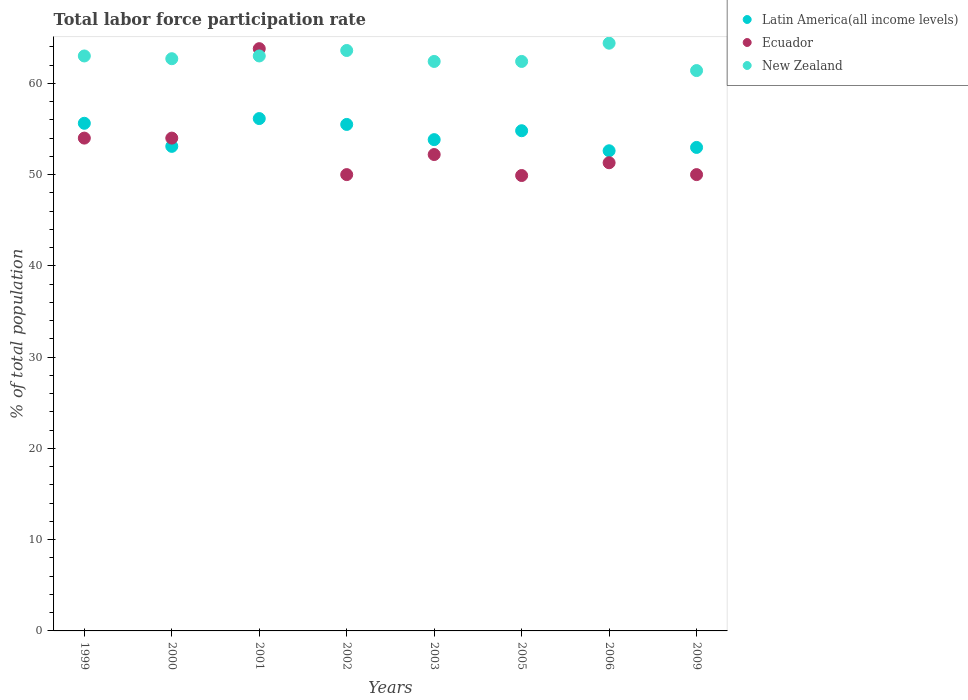What is the total labor force participation rate in Ecuador in 2003?
Provide a succinct answer. 52.2. Across all years, what is the maximum total labor force participation rate in New Zealand?
Your answer should be compact. 64.4. Across all years, what is the minimum total labor force participation rate in New Zealand?
Give a very brief answer. 61.4. In which year was the total labor force participation rate in Latin America(all income levels) maximum?
Your answer should be very brief. 2001. In which year was the total labor force participation rate in New Zealand minimum?
Offer a very short reply. 2009. What is the total total labor force participation rate in Latin America(all income levels) in the graph?
Give a very brief answer. 434.59. What is the difference between the total labor force participation rate in New Zealand in 1999 and that in 2003?
Offer a very short reply. 0.6. What is the difference between the total labor force participation rate in Ecuador in 2003 and the total labor force participation rate in New Zealand in 2000?
Ensure brevity in your answer.  -10.5. What is the average total labor force participation rate in Latin America(all income levels) per year?
Make the answer very short. 54.32. In the year 2005, what is the difference between the total labor force participation rate in Ecuador and total labor force participation rate in New Zealand?
Offer a terse response. -12.5. What is the ratio of the total labor force participation rate in New Zealand in 2002 to that in 2009?
Ensure brevity in your answer.  1.04. Is the total labor force participation rate in Ecuador in 2000 less than that in 2001?
Your answer should be compact. Yes. What is the difference between the highest and the second highest total labor force participation rate in Ecuador?
Give a very brief answer. 9.8. What is the difference between the highest and the lowest total labor force participation rate in Ecuador?
Provide a short and direct response. 13.9. In how many years, is the total labor force participation rate in Latin America(all income levels) greater than the average total labor force participation rate in Latin America(all income levels) taken over all years?
Make the answer very short. 4. Is it the case that in every year, the sum of the total labor force participation rate in New Zealand and total labor force participation rate in Ecuador  is greater than the total labor force participation rate in Latin America(all income levels)?
Offer a very short reply. Yes. Is the total labor force participation rate in Ecuador strictly less than the total labor force participation rate in Latin America(all income levels) over the years?
Provide a short and direct response. No. How many years are there in the graph?
Provide a succinct answer. 8. What is the difference between two consecutive major ticks on the Y-axis?
Give a very brief answer. 10. Does the graph contain any zero values?
Give a very brief answer. No. Where does the legend appear in the graph?
Ensure brevity in your answer.  Top right. How many legend labels are there?
Offer a terse response. 3. How are the legend labels stacked?
Offer a very short reply. Vertical. What is the title of the graph?
Give a very brief answer. Total labor force participation rate. What is the label or title of the Y-axis?
Provide a succinct answer. % of total population. What is the % of total population of Latin America(all income levels) in 1999?
Ensure brevity in your answer.  55.62. What is the % of total population of Latin America(all income levels) in 2000?
Offer a terse response. 53.09. What is the % of total population of Ecuador in 2000?
Make the answer very short. 54. What is the % of total population in New Zealand in 2000?
Provide a succinct answer. 62.7. What is the % of total population in Latin America(all income levels) in 2001?
Offer a terse response. 56.14. What is the % of total population of Ecuador in 2001?
Provide a succinct answer. 63.8. What is the % of total population in New Zealand in 2001?
Offer a terse response. 63. What is the % of total population of Latin America(all income levels) in 2002?
Provide a short and direct response. 55.5. What is the % of total population in New Zealand in 2002?
Offer a very short reply. 63.6. What is the % of total population of Latin America(all income levels) in 2003?
Offer a terse response. 53.83. What is the % of total population in Ecuador in 2003?
Your response must be concise. 52.2. What is the % of total population of New Zealand in 2003?
Make the answer very short. 62.4. What is the % of total population of Latin America(all income levels) in 2005?
Your answer should be compact. 54.81. What is the % of total population in Ecuador in 2005?
Your answer should be compact. 49.9. What is the % of total population in New Zealand in 2005?
Your response must be concise. 62.4. What is the % of total population in Latin America(all income levels) in 2006?
Offer a very short reply. 52.61. What is the % of total population of Ecuador in 2006?
Your answer should be compact. 51.3. What is the % of total population in New Zealand in 2006?
Your response must be concise. 64.4. What is the % of total population in Latin America(all income levels) in 2009?
Offer a very short reply. 52.98. What is the % of total population in New Zealand in 2009?
Provide a short and direct response. 61.4. Across all years, what is the maximum % of total population of Latin America(all income levels)?
Offer a very short reply. 56.14. Across all years, what is the maximum % of total population of Ecuador?
Your answer should be compact. 63.8. Across all years, what is the maximum % of total population of New Zealand?
Your answer should be compact. 64.4. Across all years, what is the minimum % of total population of Latin America(all income levels)?
Keep it short and to the point. 52.61. Across all years, what is the minimum % of total population of Ecuador?
Make the answer very short. 49.9. Across all years, what is the minimum % of total population in New Zealand?
Offer a terse response. 61.4. What is the total % of total population of Latin America(all income levels) in the graph?
Offer a terse response. 434.59. What is the total % of total population of Ecuador in the graph?
Give a very brief answer. 425.2. What is the total % of total population in New Zealand in the graph?
Make the answer very short. 502.9. What is the difference between the % of total population of Latin America(all income levels) in 1999 and that in 2000?
Offer a very short reply. 2.53. What is the difference between the % of total population of Latin America(all income levels) in 1999 and that in 2001?
Ensure brevity in your answer.  -0.52. What is the difference between the % of total population of Ecuador in 1999 and that in 2001?
Ensure brevity in your answer.  -9.8. What is the difference between the % of total population of Latin America(all income levels) in 1999 and that in 2002?
Provide a short and direct response. 0.13. What is the difference between the % of total population in Ecuador in 1999 and that in 2002?
Your answer should be very brief. 4. What is the difference between the % of total population of New Zealand in 1999 and that in 2002?
Make the answer very short. -0.6. What is the difference between the % of total population in Latin America(all income levels) in 1999 and that in 2003?
Keep it short and to the point. 1.79. What is the difference between the % of total population of New Zealand in 1999 and that in 2003?
Provide a short and direct response. 0.6. What is the difference between the % of total population of Latin America(all income levels) in 1999 and that in 2005?
Offer a terse response. 0.82. What is the difference between the % of total population in New Zealand in 1999 and that in 2005?
Make the answer very short. 0.6. What is the difference between the % of total population in Latin America(all income levels) in 1999 and that in 2006?
Offer a terse response. 3.01. What is the difference between the % of total population in New Zealand in 1999 and that in 2006?
Provide a short and direct response. -1.4. What is the difference between the % of total population of Latin America(all income levels) in 1999 and that in 2009?
Ensure brevity in your answer.  2.64. What is the difference between the % of total population in Latin America(all income levels) in 2000 and that in 2001?
Give a very brief answer. -3.05. What is the difference between the % of total population in New Zealand in 2000 and that in 2001?
Your answer should be very brief. -0.3. What is the difference between the % of total population of Latin America(all income levels) in 2000 and that in 2002?
Give a very brief answer. -2.4. What is the difference between the % of total population of New Zealand in 2000 and that in 2002?
Offer a very short reply. -0.9. What is the difference between the % of total population of Latin America(all income levels) in 2000 and that in 2003?
Provide a short and direct response. -0.74. What is the difference between the % of total population of New Zealand in 2000 and that in 2003?
Give a very brief answer. 0.3. What is the difference between the % of total population in Latin America(all income levels) in 2000 and that in 2005?
Your answer should be compact. -1.71. What is the difference between the % of total population in Latin America(all income levels) in 2000 and that in 2006?
Offer a terse response. 0.48. What is the difference between the % of total population of Ecuador in 2000 and that in 2006?
Provide a succinct answer. 2.7. What is the difference between the % of total population of New Zealand in 2000 and that in 2006?
Your answer should be very brief. -1.7. What is the difference between the % of total population in Latin America(all income levels) in 2000 and that in 2009?
Your answer should be compact. 0.12. What is the difference between the % of total population in New Zealand in 2000 and that in 2009?
Provide a succinct answer. 1.3. What is the difference between the % of total population of Latin America(all income levels) in 2001 and that in 2002?
Ensure brevity in your answer.  0.64. What is the difference between the % of total population in Ecuador in 2001 and that in 2002?
Your answer should be very brief. 13.8. What is the difference between the % of total population of New Zealand in 2001 and that in 2002?
Ensure brevity in your answer.  -0.6. What is the difference between the % of total population of Latin America(all income levels) in 2001 and that in 2003?
Your answer should be compact. 2.31. What is the difference between the % of total population in Ecuador in 2001 and that in 2003?
Offer a terse response. 11.6. What is the difference between the % of total population in Latin America(all income levels) in 2001 and that in 2005?
Ensure brevity in your answer.  1.33. What is the difference between the % of total population of New Zealand in 2001 and that in 2005?
Ensure brevity in your answer.  0.6. What is the difference between the % of total population in Latin America(all income levels) in 2001 and that in 2006?
Your answer should be compact. 3.53. What is the difference between the % of total population of Ecuador in 2001 and that in 2006?
Offer a very short reply. 12.5. What is the difference between the % of total population in Latin America(all income levels) in 2001 and that in 2009?
Keep it short and to the point. 3.16. What is the difference between the % of total population of Ecuador in 2001 and that in 2009?
Your answer should be very brief. 13.8. What is the difference between the % of total population in New Zealand in 2001 and that in 2009?
Offer a terse response. 1.6. What is the difference between the % of total population of Latin America(all income levels) in 2002 and that in 2003?
Provide a succinct answer. 1.67. What is the difference between the % of total population in Ecuador in 2002 and that in 2003?
Your answer should be compact. -2.2. What is the difference between the % of total population in New Zealand in 2002 and that in 2003?
Your answer should be very brief. 1.2. What is the difference between the % of total population in Latin America(all income levels) in 2002 and that in 2005?
Offer a very short reply. 0.69. What is the difference between the % of total population of Ecuador in 2002 and that in 2005?
Your answer should be compact. 0.1. What is the difference between the % of total population in Latin America(all income levels) in 2002 and that in 2006?
Give a very brief answer. 2.89. What is the difference between the % of total population in Ecuador in 2002 and that in 2006?
Your response must be concise. -1.3. What is the difference between the % of total population in New Zealand in 2002 and that in 2006?
Your response must be concise. -0.8. What is the difference between the % of total population of Latin America(all income levels) in 2002 and that in 2009?
Provide a short and direct response. 2.52. What is the difference between the % of total population of Ecuador in 2002 and that in 2009?
Give a very brief answer. 0. What is the difference between the % of total population in New Zealand in 2002 and that in 2009?
Your answer should be compact. 2.2. What is the difference between the % of total population in Latin America(all income levels) in 2003 and that in 2005?
Keep it short and to the point. -0.98. What is the difference between the % of total population of Ecuador in 2003 and that in 2005?
Your answer should be compact. 2.3. What is the difference between the % of total population in New Zealand in 2003 and that in 2005?
Give a very brief answer. 0. What is the difference between the % of total population in Latin America(all income levels) in 2003 and that in 2006?
Provide a succinct answer. 1.22. What is the difference between the % of total population of Ecuador in 2003 and that in 2006?
Provide a succinct answer. 0.9. What is the difference between the % of total population of Latin America(all income levels) in 2003 and that in 2009?
Your answer should be compact. 0.85. What is the difference between the % of total population of Ecuador in 2003 and that in 2009?
Give a very brief answer. 2.2. What is the difference between the % of total population in New Zealand in 2003 and that in 2009?
Your answer should be very brief. 1. What is the difference between the % of total population of Latin America(all income levels) in 2005 and that in 2006?
Ensure brevity in your answer.  2.2. What is the difference between the % of total population in Latin America(all income levels) in 2005 and that in 2009?
Ensure brevity in your answer.  1.83. What is the difference between the % of total population in Latin America(all income levels) in 2006 and that in 2009?
Your answer should be compact. -0.37. What is the difference between the % of total population of New Zealand in 2006 and that in 2009?
Your answer should be compact. 3. What is the difference between the % of total population of Latin America(all income levels) in 1999 and the % of total population of Ecuador in 2000?
Your answer should be very brief. 1.62. What is the difference between the % of total population of Latin America(all income levels) in 1999 and the % of total population of New Zealand in 2000?
Offer a terse response. -7.08. What is the difference between the % of total population of Ecuador in 1999 and the % of total population of New Zealand in 2000?
Offer a very short reply. -8.7. What is the difference between the % of total population in Latin America(all income levels) in 1999 and the % of total population in Ecuador in 2001?
Give a very brief answer. -8.18. What is the difference between the % of total population in Latin America(all income levels) in 1999 and the % of total population in New Zealand in 2001?
Keep it short and to the point. -7.38. What is the difference between the % of total population in Ecuador in 1999 and the % of total population in New Zealand in 2001?
Make the answer very short. -9. What is the difference between the % of total population of Latin America(all income levels) in 1999 and the % of total population of Ecuador in 2002?
Provide a succinct answer. 5.62. What is the difference between the % of total population in Latin America(all income levels) in 1999 and the % of total population in New Zealand in 2002?
Your answer should be compact. -7.98. What is the difference between the % of total population of Ecuador in 1999 and the % of total population of New Zealand in 2002?
Your answer should be very brief. -9.6. What is the difference between the % of total population in Latin America(all income levels) in 1999 and the % of total population in Ecuador in 2003?
Your answer should be very brief. 3.42. What is the difference between the % of total population of Latin America(all income levels) in 1999 and the % of total population of New Zealand in 2003?
Offer a very short reply. -6.78. What is the difference between the % of total population of Ecuador in 1999 and the % of total population of New Zealand in 2003?
Your answer should be compact. -8.4. What is the difference between the % of total population of Latin America(all income levels) in 1999 and the % of total population of Ecuador in 2005?
Ensure brevity in your answer.  5.72. What is the difference between the % of total population in Latin America(all income levels) in 1999 and the % of total population in New Zealand in 2005?
Your response must be concise. -6.78. What is the difference between the % of total population in Latin America(all income levels) in 1999 and the % of total population in Ecuador in 2006?
Keep it short and to the point. 4.32. What is the difference between the % of total population in Latin America(all income levels) in 1999 and the % of total population in New Zealand in 2006?
Offer a very short reply. -8.78. What is the difference between the % of total population of Ecuador in 1999 and the % of total population of New Zealand in 2006?
Your answer should be very brief. -10.4. What is the difference between the % of total population of Latin America(all income levels) in 1999 and the % of total population of Ecuador in 2009?
Make the answer very short. 5.62. What is the difference between the % of total population of Latin America(all income levels) in 1999 and the % of total population of New Zealand in 2009?
Your answer should be compact. -5.78. What is the difference between the % of total population of Ecuador in 1999 and the % of total population of New Zealand in 2009?
Keep it short and to the point. -7.4. What is the difference between the % of total population in Latin America(all income levels) in 2000 and the % of total population in Ecuador in 2001?
Make the answer very short. -10.71. What is the difference between the % of total population in Latin America(all income levels) in 2000 and the % of total population in New Zealand in 2001?
Offer a terse response. -9.9. What is the difference between the % of total population of Ecuador in 2000 and the % of total population of New Zealand in 2001?
Provide a succinct answer. -9. What is the difference between the % of total population in Latin America(all income levels) in 2000 and the % of total population in Ecuador in 2002?
Provide a succinct answer. 3.1. What is the difference between the % of total population in Latin America(all income levels) in 2000 and the % of total population in New Zealand in 2002?
Give a very brief answer. -10.51. What is the difference between the % of total population of Latin America(all income levels) in 2000 and the % of total population of Ecuador in 2003?
Provide a short and direct response. 0.9. What is the difference between the % of total population of Latin America(all income levels) in 2000 and the % of total population of New Zealand in 2003?
Make the answer very short. -9.3. What is the difference between the % of total population of Ecuador in 2000 and the % of total population of New Zealand in 2003?
Offer a terse response. -8.4. What is the difference between the % of total population of Latin America(all income levels) in 2000 and the % of total population of Ecuador in 2005?
Give a very brief answer. 3.19. What is the difference between the % of total population in Latin America(all income levels) in 2000 and the % of total population in New Zealand in 2005?
Offer a terse response. -9.3. What is the difference between the % of total population of Ecuador in 2000 and the % of total population of New Zealand in 2005?
Offer a very short reply. -8.4. What is the difference between the % of total population of Latin America(all income levels) in 2000 and the % of total population of Ecuador in 2006?
Offer a very short reply. 1.79. What is the difference between the % of total population in Latin America(all income levels) in 2000 and the % of total population in New Zealand in 2006?
Ensure brevity in your answer.  -11.3. What is the difference between the % of total population of Latin America(all income levels) in 2000 and the % of total population of Ecuador in 2009?
Offer a very short reply. 3.1. What is the difference between the % of total population of Latin America(all income levels) in 2000 and the % of total population of New Zealand in 2009?
Provide a short and direct response. -8.3. What is the difference between the % of total population in Ecuador in 2000 and the % of total population in New Zealand in 2009?
Give a very brief answer. -7.4. What is the difference between the % of total population in Latin America(all income levels) in 2001 and the % of total population in Ecuador in 2002?
Ensure brevity in your answer.  6.14. What is the difference between the % of total population of Latin America(all income levels) in 2001 and the % of total population of New Zealand in 2002?
Keep it short and to the point. -7.46. What is the difference between the % of total population in Ecuador in 2001 and the % of total population in New Zealand in 2002?
Make the answer very short. 0.2. What is the difference between the % of total population of Latin America(all income levels) in 2001 and the % of total population of Ecuador in 2003?
Offer a terse response. 3.94. What is the difference between the % of total population of Latin America(all income levels) in 2001 and the % of total population of New Zealand in 2003?
Provide a short and direct response. -6.26. What is the difference between the % of total population of Ecuador in 2001 and the % of total population of New Zealand in 2003?
Offer a terse response. 1.4. What is the difference between the % of total population of Latin America(all income levels) in 2001 and the % of total population of Ecuador in 2005?
Give a very brief answer. 6.24. What is the difference between the % of total population in Latin America(all income levels) in 2001 and the % of total population in New Zealand in 2005?
Your answer should be very brief. -6.26. What is the difference between the % of total population of Ecuador in 2001 and the % of total population of New Zealand in 2005?
Ensure brevity in your answer.  1.4. What is the difference between the % of total population in Latin America(all income levels) in 2001 and the % of total population in Ecuador in 2006?
Give a very brief answer. 4.84. What is the difference between the % of total population of Latin America(all income levels) in 2001 and the % of total population of New Zealand in 2006?
Provide a succinct answer. -8.26. What is the difference between the % of total population in Ecuador in 2001 and the % of total population in New Zealand in 2006?
Your response must be concise. -0.6. What is the difference between the % of total population of Latin America(all income levels) in 2001 and the % of total population of Ecuador in 2009?
Provide a succinct answer. 6.14. What is the difference between the % of total population of Latin America(all income levels) in 2001 and the % of total population of New Zealand in 2009?
Your answer should be very brief. -5.26. What is the difference between the % of total population in Ecuador in 2001 and the % of total population in New Zealand in 2009?
Provide a succinct answer. 2.4. What is the difference between the % of total population in Latin America(all income levels) in 2002 and the % of total population in Ecuador in 2003?
Give a very brief answer. 3.3. What is the difference between the % of total population of Latin America(all income levels) in 2002 and the % of total population of New Zealand in 2003?
Your answer should be compact. -6.9. What is the difference between the % of total population in Ecuador in 2002 and the % of total population in New Zealand in 2003?
Provide a short and direct response. -12.4. What is the difference between the % of total population in Latin America(all income levels) in 2002 and the % of total population in Ecuador in 2005?
Your response must be concise. 5.6. What is the difference between the % of total population of Latin America(all income levels) in 2002 and the % of total population of New Zealand in 2005?
Provide a short and direct response. -6.9. What is the difference between the % of total population in Ecuador in 2002 and the % of total population in New Zealand in 2005?
Keep it short and to the point. -12.4. What is the difference between the % of total population in Latin America(all income levels) in 2002 and the % of total population in Ecuador in 2006?
Your answer should be compact. 4.2. What is the difference between the % of total population of Latin America(all income levels) in 2002 and the % of total population of New Zealand in 2006?
Your answer should be compact. -8.9. What is the difference between the % of total population in Ecuador in 2002 and the % of total population in New Zealand in 2006?
Offer a terse response. -14.4. What is the difference between the % of total population in Latin America(all income levels) in 2002 and the % of total population in Ecuador in 2009?
Your answer should be compact. 5.5. What is the difference between the % of total population of Latin America(all income levels) in 2002 and the % of total population of New Zealand in 2009?
Ensure brevity in your answer.  -5.9. What is the difference between the % of total population in Ecuador in 2002 and the % of total population in New Zealand in 2009?
Keep it short and to the point. -11.4. What is the difference between the % of total population in Latin America(all income levels) in 2003 and the % of total population in Ecuador in 2005?
Provide a short and direct response. 3.93. What is the difference between the % of total population in Latin America(all income levels) in 2003 and the % of total population in New Zealand in 2005?
Make the answer very short. -8.57. What is the difference between the % of total population of Latin America(all income levels) in 2003 and the % of total population of Ecuador in 2006?
Provide a succinct answer. 2.53. What is the difference between the % of total population in Latin America(all income levels) in 2003 and the % of total population in New Zealand in 2006?
Ensure brevity in your answer.  -10.57. What is the difference between the % of total population of Ecuador in 2003 and the % of total population of New Zealand in 2006?
Your response must be concise. -12.2. What is the difference between the % of total population in Latin America(all income levels) in 2003 and the % of total population in Ecuador in 2009?
Your answer should be very brief. 3.83. What is the difference between the % of total population in Latin America(all income levels) in 2003 and the % of total population in New Zealand in 2009?
Provide a short and direct response. -7.57. What is the difference between the % of total population of Ecuador in 2003 and the % of total population of New Zealand in 2009?
Your response must be concise. -9.2. What is the difference between the % of total population in Latin America(all income levels) in 2005 and the % of total population in Ecuador in 2006?
Provide a succinct answer. 3.51. What is the difference between the % of total population in Latin America(all income levels) in 2005 and the % of total population in New Zealand in 2006?
Make the answer very short. -9.59. What is the difference between the % of total population in Latin America(all income levels) in 2005 and the % of total population in Ecuador in 2009?
Keep it short and to the point. 4.81. What is the difference between the % of total population in Latin America(all income levels) in 2005 and the % of total population in New Zealand in 2009?
Your answer should be very brief. -6.59. What is the difference between the % of total population of Latin America(all income levels) in 2006 and the % of total population of Ecuador in 2009?
Give a very brief answer. 2.61. What is the difference between the % of total population in Latin America(all income levels) in 2006 and the % of total population in New Zealand in 2009?
Make the answer very short. -8.79. What is the average % of total population in Latin America(all income levels) per year?
Your response must be concise. 54.32. What is the average % of total population of Ecuador per year?
Keep it short and to the point. 53.15. What is the average % of total population of New Zealand per year?
Make the answer very short. 62.86. In the year 1999, what is the difference between the % of total population of Latin America(all income levels) and % of total population of Ecuador?
Your response must be concise. 1.62. In the year 1999, what is the difference between the % of total population in Latin America(all income levels) and % of total population in New Zealand?
Give a very brief answer. -7.38. In the year 2000, what is the difference between the % of total population of Latin America(all income levels) and % of total population of Ecuador?
Give a very brief answer. -0.91. In the year 2000, what is the difference between the % of total population in Latin America(all income levels) and % of total population in New Zealand?
Your answer should be compact. -9.61. In the year 2001, what is the difference between the % of total population in Latin America(all income levels) and % of total population in Ecuador?
Provide a short and direct response. -7.66. In the year 2001, what is the difference between the % of total population of Latin America(all income levels) and % of total population of New Zealand?
Offer a terse response. -6.86. In the year 2001, what is the difference between the % of total population in Ecuador and % of total population in New Zealand?
Give a very brief answer. 0.8. In the year 2002, what is the difference between the % of total population in Latin America(all income levels) and % of total population in Ecuador?
Your answer should be compact. 5.5. In the year 2002, what is the difference between the % of total population in Latin America(all income levels) and % of total population in New Zealand?
Your answer should be very brief. -8.1. In the year 2002, what is the difference between the % of total population in Ecuador and % of total population in New Zealand?
Ensure brevity in your answer.  -13.6. In the year 2003, what is the difference between the % of total population of Latin America(all income levels) and % of total population of Ecuador?
Provide a succinct answer. 1.63. In the year 2003, what is the difference between the % of total population in Latin America(all income levels) and % of total population in New Zealand?
Your answer should be very brief. -8.57. In the year 2005, what is the difference between the % of total population of Latin America(all income levels) and % of total population of Ecuador?
Make the answer very short. 4.91. In the year 2005, what is the difference between the % of total population in Latin America(all income levels) and % of total population in New Zealand?
Give a very brief answer. -7.59. In the year 2005, what is the difference between the % of total population in Ecuador and % of total population in New Zealand?
Give a very brief answer. -12.5. In the year 2006, what is the difference between the % of total population of Latin America(all income levels) and % of total population of Ecuador?
Make the answer very short. 1.31. In the year 2006, what is the difference between the % of total population of Latin America(all income levels) and % of total population of New Zealand?
Ensure brevity in your answer.  -11.79. In the year 2006, what is the difference between the % of total population in Ecuador and % of total population in New Zealand?
Make the answer very short. -13.1. In the year 2009, what is the difference between the % of total population of Latin America(all income levels) and % of total population of Ecuador?
Give a very brief answer. 2.98. In the year 2009, what is the difference between the % of total population in Latin America(all income levels) and % of total population in New Zealand?
Make the answer very short. -8.42. What is the ratio of the % of total population in Latin America(all income levels) in 1999 to that in 2000?
Ensure brevity in your answer.  1.05. What is the ratio of the % of total population of Latin America(all income levels) in 1999 to that in 2001?
Your response must be concise. 0.99. What is the ratio of the % of total population of Ecuador in 1999 to that in 2001?
Your answer should be very brief. 0.85. What is the ratio of the % of total population in New Zealand in 1999 to that in 2001?
Offer a very short reply. 1. What is the ratio of the % of total population of Ecuador in 1999 to that in 2002?
Your response must be concise. 1.08. What is the ratio of the % of total population of New Zealand in 1999 to that in 2002?
Your answer should be compact. 0.99. What is the ratio of the % of total population of Ecuador in 1999 to that in 2003?
Give a very brief answer. 1.03. What is the ratio of the % of total population of New Zealand in 1999 to that in 2003?
Your answer should be very brief. 1.01. What is the ratio of the % of total population in Latin America(all income levels) in 1999 to that in 2005?
Provide a short and direct response. 1.01. What is the ratio of the % of total population in Ecuador in 1999 to that in 2005?
Offer a terse response. 1.08. What is the ratio of the % of total population in New Zealand in 1999 to that in 2005?
Keep it short and to the point. 1.01. What is the ratio of the % of total population of Latin America(all income levels) in 1999 to that in 2006?
Your answer should be very brief. 1.06. What is the ratio of the % of total population in Ecuador in 1999 to that in 2006?
Make the answer very short. 1.05. What is the ratio of the % of total population in New Zealand in 1999 to that in 2006?
Make the answer very short. 0.98. What is the ratio of the % of total population in Latin America(all income levels) in 1999 to that in 2009?
Your answer should be very brief. 1.05. What is the ratio of the % of total population in Ecuador in 1999 to that in 2009?
Offer a very short reply. 1.08. What is the ratio of the % of total population of New Zealand in 1999 to that in 2009?
Give a very brief answer. 1.03. What is the ratio of the % of total population of Latin America(all income levels) in 2000 to that in 2001?
Provide a succinct answer. 0.95. What is the ratio of the % of total population of Ecuador in 2000 to that in 2001?
Your response must be concise. 0.85. What is the ratio of the % of total population in Latin America(all income levels) in 2000 to that in 2002?
Your answer should be compact. 0.96. What is the ratio of the % of total population in New Zealand in 2000 to that in 2002?
Provide a succinct answer. 0.99. What is the ratio of the % of total population of Latin America(all income levels) in 2000 to that in 2003?
Give a very brief answer. 0.99. What is the ratio of the % of total population of Ecuador in 2000 to that in 2003?
Make the answer very short. 1.03. What is the ratio of the % of total population in New Zealand in 2000 to that in 2003?
Ensure brevity in your answer.  1. What is the ratio of the % of total population of Latin America(all income levels) in 2000 to that in 2005?
Provide a short and direct response. 0.97. What is the ratio of the % of total population of Ecuador in 2000 to that in 2005?
Your answer should be compact. 1.08. What is the ratio of the % of total population of Latin America(all income levels) in 2000 to that in 2006?
Your answer should be compact. 1.01. What is the ratio of the % of total population in Ecuador in 2000 to that in 2006?
Make the answer very short. 1.05. What is the ratio of the % of total population of New Zealand in 2000 to that in 2006?
Your answer should be very brief. 0.97. What is the ratio of the % of total population in Ecuador in 2000 to that in 2009?
Offer a terse response. 1.08. What is the ratio of the % of total population in New Zealand in 2000 to that in 2009?
Keep it short and to the point. 1.02. What is the ratio of the % of total population of Latin America(all income levels) in 2001 to that in 2002?
Your answer should be compact. 1.01. What is the ratio of the % of total population in Ecuador in 2001 to that in 2002?
Your answer should be compact. 1.28. What is the ratio of the % of total population of New Zealand in 2001 to that in 2002?
Make the answer very short. 0.99. What is the ratio of the % of total population of Latin America(all income levels) in 2001 to that in 2003?
Offer a terse response. 1.04. What is the ratio of the % of total population of Ecuador in 2001 to that in 2003?
Offer a terse response. 1.22. What is the ratio of the % of total population of New Zealand in 2001 to that in 2003?
Your response must be concise. 1.01. What is the ratio of the % of total population of Latin America(all income levels) in 2001 to that in 2005?
Give a very brief answer. 1.02. What is the ratio of the % of total population of Ecuador in 2001 to that in 2005?
Keep it short and to the point. 1.28. What is the ratio of the % of total population of New Zealand in 2001 to that in 2005?
Keep it short and to the point. 1.01. What is the ratio of the % of total population in Latin America(all income levels) in 2001 to that in 2006?
Your response must be concise. 1.07. What is the ratio of the % of total population in Ecuador in 2001 to that in 2006?
Give a very brief answer. 1.24. What is the ratio of the % of total population in New Zealand in 2001 to that in 2006?
Make the answer very short. 0.98. What is the ratio of the % of total population of Latin America(all income levels) in 2001 to that in 2009?
Offer a terse response. 1.06. What is the ratio of the % of total population of Ecuador in 2001 to that in 2009?
Keep it short and to the point. 1.28. What is the ratio of the % of total population in New Zealand in 2001 to that in 2009?
Provide a succinct answer. 1.03. What is the ratio of the % of total population of Latin America(all income levels) in 2002 to that in 2003?
Make the answer very short. 1.03. What is the ratio of the % of total population of Ecuador in 2002 to that in 2003?
Offer a terse response. 0.96. What is the ratio of the % of total population of New Zealand in 2002 to that in 2003?
Give a very brief answer. 1.02. What is the ratio of the % of total population of Latin America(all income levels) in 2002 to that in 2005?
Offer a very short reply. 1.01. What is the ratio of the % of total population of New Zealand in 2002 to that in 2005?
Ensure brevity in your answer.  1.02. What is the ratio of the % of total population of Latin America(all income levels) in 2002 to that in 2006?
Keep it short and to the point. 1.05. What is the ratio of the % of total population of Ecuador in 2002 to that in 2006?
Your answer should be very brief. 0.97. What is the ratio of the % of total population of New Zealand in 2002 to that in 2006?
Keep it short and to the point. 0.99. What is the ratio of the % of total population of Latin America(all income levels) in 2002 to that in 2009?
Provide a short and direct response. 1.05. What is the ratio of the % of total population in Ecuador in 2002 to that in 2009?
Your response must be concise. 1. What is the ratio of the % of total population in New Zealand in 2002 to that in 2009?
Provide a succinct answer. 1.04. What is the ratio of the % of total population of Latin America(all income levels) in 2003 to that in 2005?
Your answer should be very brief. 0.98. What is the ratio of the % of total population of Ecuador in 2003 to that in 2005?
Ensure brevity in your answer.  1.05. What is the ratio of the % of total population in Latin America(all income levels) in 2003 to that in 2006?
Give a very brief answer. 1.02. What is the ratio of the % of total population of Ecuador in 2003 to that in 2006?
Keep it short and to the point. 1.02. What is the ratio of the % of total population in New Zealand in 2003 to that in 2006?
Your answer should be compact. 0.97. What is the ratio of the % of total population in Latin America(all income levels) in 2003 to that in 2009?
Your response must be concise. 1.02. What is the ratio of the % of total population in Ecuador in 2003 to that in 2009?
Keep it short and to the point. 1.04. What is the ratio of the % of total population of New Zealand in 2003 to that in 2009?
Ensure brevity in your answer.  1.02. What is the ratio of the % of total population of Latin America(all income levels) in 2005 to that in 2006?
Give a very brief answer. 1.04. What is the ratio of the % of total population of Ecuador in 2005 to that in 2006?
Your answer should be compact. 0.97. What is the ratio of the % of total population of New Zealand in 2005 to that in 2006?
Your answer should be compact. 0.97. What is the ratio of the % of total population of Latin America(all income levels) in 2005 to that in 2009?
Provide a short and direct response. 1.03. What is the ratio of the % of total population in Ecuador in 2005 to that in 2009?
Your answer should be compact. 1. What is the ratio of the % of total population of New Zealand in 2005 to that in 2009?
Your answer should be compact. 1.02. What is the ratio of the % of total population in Latin America(all income levels) in 2006 to that in 2009?
Offer a very short reply. 0.99. What is the ratio of the % of total population of Ecuador in 2006 to that in 2009?
Give a very brief answer. 1.03. What is the ratio of the % of total population of New Zealand in 2006 to that in 2009?
Keep it short and to the point. 1.05. What is the difference between the highest and the second highest % of total population in Latin America(all income levels)?
Keep it short and to the point. 0.52. What is the difference between the highest and the second highest % of total population of Ecuador?
Give a very brief answer. 9.8. What is the difference between the highest and the second highest % of total population in New Zealand?
Keep it short and to the point. 0.8. What is the difference between the highest and the lowest % of total population of Latin America(all income levels)?
Ensure brevity in your answer.  3.53. What is the difference between the highest and the lowest % of total population of New Zealand?
Provide a succinct answer. 3. 